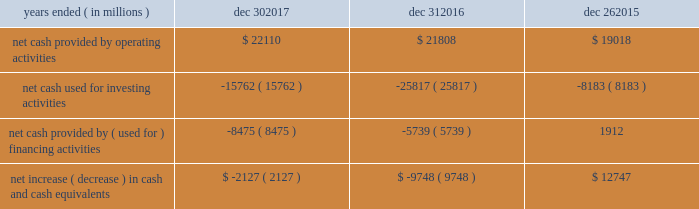In summary , our cash flows for each period were as follows : years ended ( in millions ) dec 30 , dec 31 , dec 26 .
Operating activities cash provided by operating activities is net income adjusted for certain non-cash items and changes in assets and liabilities .
For 2017 compared to 2016 , the $ 302 million increase in cash provided by operating activities was due to changes to working capital partially offset by adjustments for non-cash items and lower net income .
Tax reform did not have an impact on our 2017 cash provided by operating activities .
The increase in cash provided by operating activities was driven by increased income before taxes and $ 1.0 billion receipts of customer deposits .
These increases were partially offset by increased inventory and accounts receivable .
Income taxes paid , net of refunds , in 2017 compared to 2016 were $ 2.9 billion higher due to higher income before taxes , taxable gains on sales of asml , and taxes on the isecg divestiture .
We expect approximately $ 2.0 billion of additional customer deposits in 2018 .
For 2016 compared to 2015 , the $ 2.8 billion increase in cash provided by operating activities was due to adjustments for non-cash items and changes in working capital , partially offset by lower net income .
The adjustments for non-cash items were higher in 2016 primarily due to restructuring and other charges and the change in deferred taxes , partially offset by lower depreciation .
Investing activities investing cash flows consist primarily of capital expenditures ; investment purchases , sales , maturities , and disposals ; and proceeds from divestitures and cash used for acquisitions .
Our capital expenditures were $ 11.8 billion in 2017 ( $ 9.6 billion in 2016 and $ 7.3 billion in 2015 ) .
The decrease in cash used for investing activities in 2017 compared to 2016 was primarily due to higher net activity of available-for sale-investments in 2017 , proceeds from our divestiture of isecg in 2017 , and higher maturities and sales of trading assets in 2017 .
This activity was partially offset by higher capital expenditures in 2017 .
The increase in cash used for investing activities in 2016 compared to 2015 was primarily due to our completed acquisition of altera , net purchases of trading assets in 2016 compared to net sales of trading assets in 2015 , and higher capital expenditures in 2016 .
This increase was partially offset by lower investments in non-marketable equity investments .
Financing activities financing cash flows consist primarily of repurchases of common stock , payment of dividends to stockholders , issuance and repayment of short-term and long-term debt , and proceeds from the sale of shares of common stock through employee equity incentive plans .
The increase in cash used for financing activities in 2017 compared to 2016 was primarily due to net long-term debt activity , which was a use of cash in 2017 compared to a source of cash in 2016 .
During 2017 , we repurchased $ 3.6 billion of common stock under our authorized common stock repurchase program , compared to $ 2.6 billion in 2016 .
As of december 30 , 2017 , $ 13.2 billion remained available for repurchasing common stock under the existing repurchase authorization limit .
We base our level of common stock repurchases on internal cash management decisions , and this level may fluctuate .
Proceeds from the sale of common stock through employee equity incentive plans totaled $ 770 million in 2017 compared to $ 1.1 billion in 2016 .
Our total dividend payments were $ 5.1 billion in 2017 compared to $ 4.9 billion in 2016 .
We have paid a cash dividend in each of the past 101 quarters .
In january 2018 , our board of directors approved an increase to our cash dividend to $ 1.20 per share on an annual basis .
The board has declared a quarterly cash dividend of $ 0.30 per share of common stock for q1 2018 .
The dividend is payable on march 1 , 2018 to stockholders of record on february 7 , 2018 .
Cash was used for financing activities in 2016 compared to cash provided by financing activities in 2015 , primarily due to fewer debt issuances and the repayment of debt in 2016 .
This activity was partially offset by repayment of commercial paper in 2015 and fewer common stock repurchases in 2016 .
Md&a - results of operations consolidated results and analysis 37 .
What was the percent of the growth of the capital expenditures from 2016 to 2017? 
Rationale: the capital expenditures increased by 22.9% from 2016 to 2017
Computations: ((11.8 - 9.6) / 9.6)
Answer: 0.22917. 